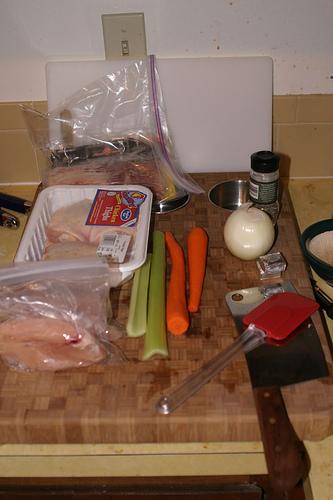What produce is in the bag?
Keep it brief. Chicken. What veggies are shown?
Be succinct. Carrots and celery. Is the light switch on or off?
Short answer required. On. Is it an indoor scene?
Give a very brief answer. Yes. 